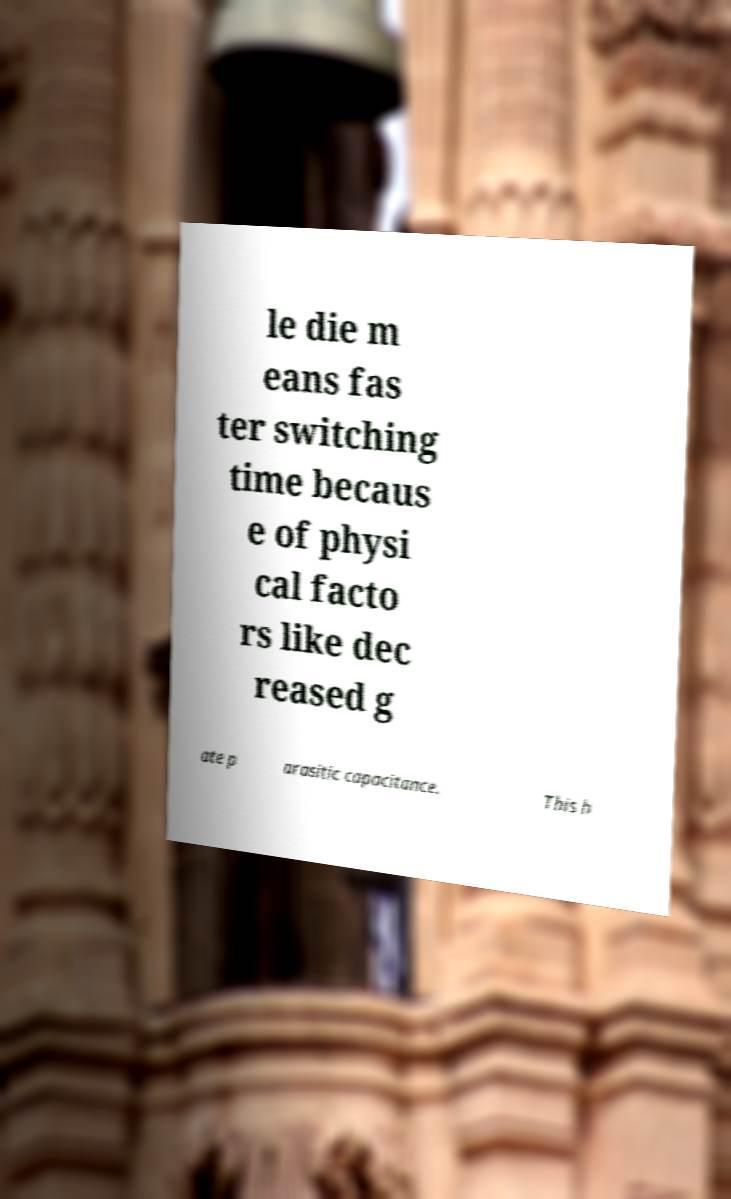Could you extract and type out the text from this image? le die m eans fas ter switching time becaus e of physi cal facto rs like dec reased g ate p arasitic capacitance. This h 